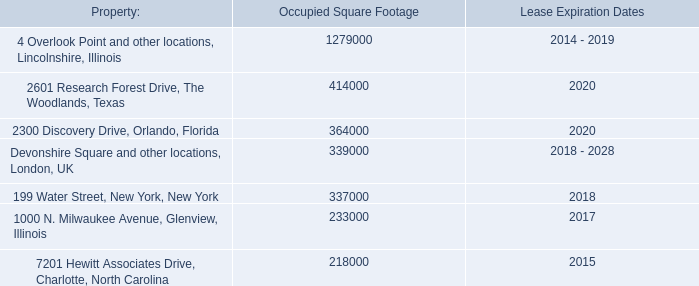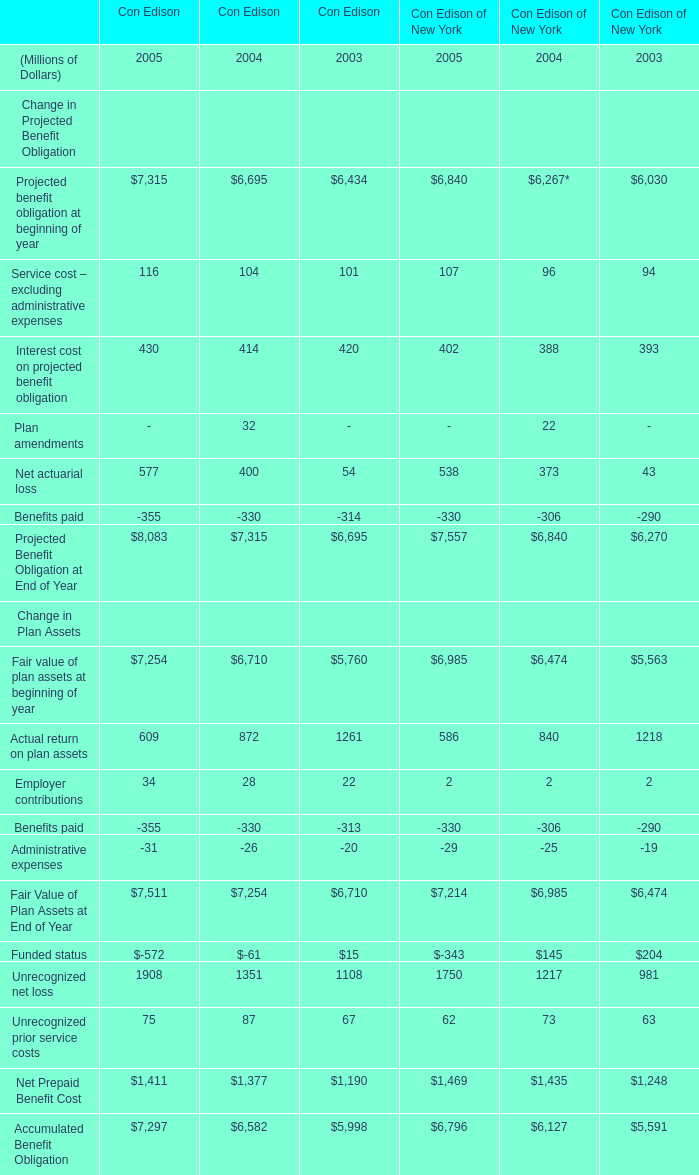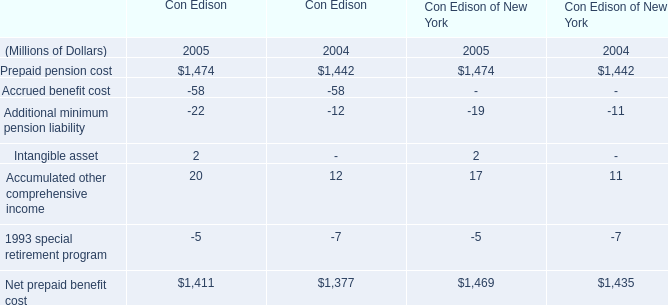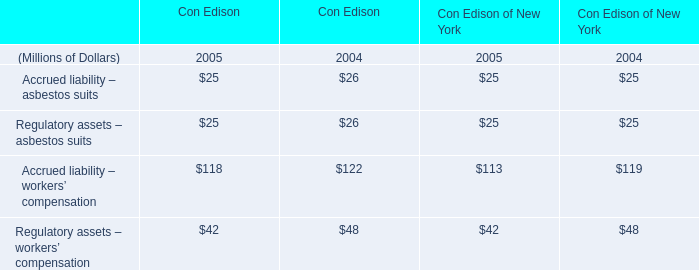In the year / section with largest amount of Prepaid pension cost, what's the sum of Prepaid pension cost? (in million) 
Computations: (1474 + 1474)
Answer: 2948.0. 